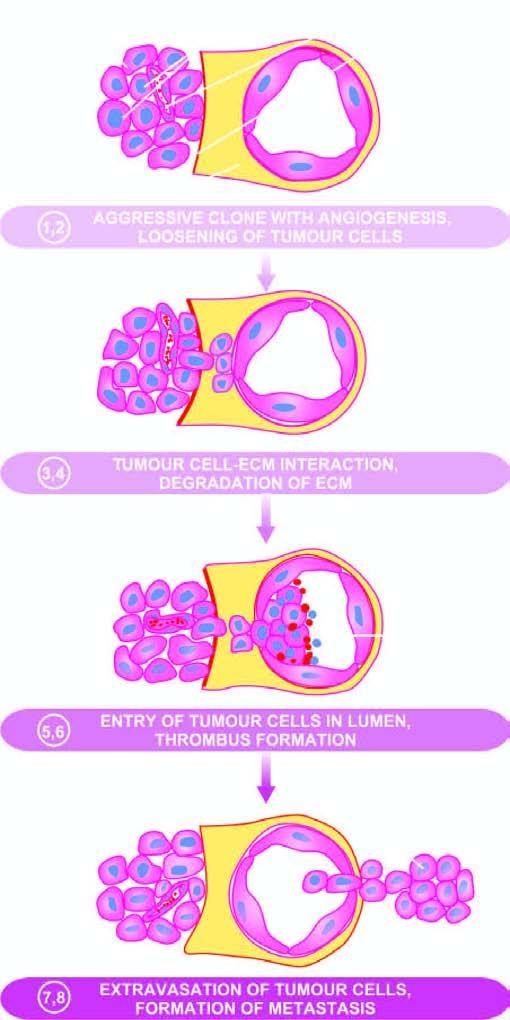what do the serial numbers in the figure correspond to in the text?
Answer the question using a single word or phrase. Their description 